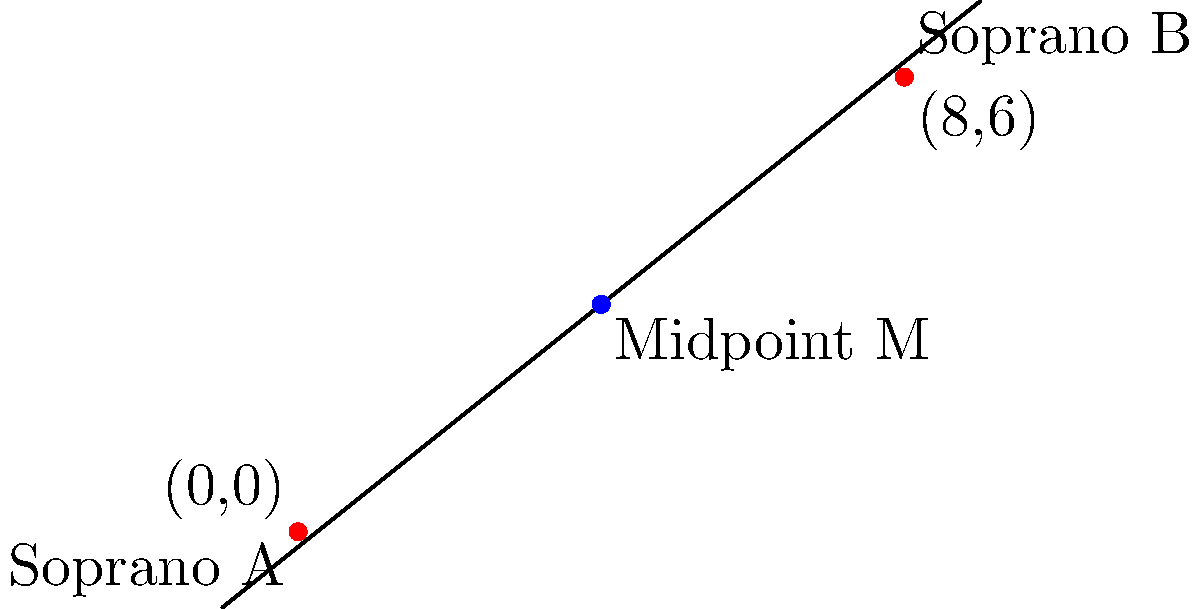Two sopranos, A and B, are positioned on stage at coordinates (0,0) and (8,6) respectively. The conductor wants to find the optimal position for harmonization, which is at the midpoint between the two singers. Calculate the coordinates of this midpoint M. To find the midpoint between two points, we use the midpoint formula:

$$ M = (\frac{x_1 + x_2}{2}, \frac{y_1 + y_2}{2}) $$

Where $(x_1, y_1)$ are the coordinates of point A, and $(x_2, y_2)$ are the coordinates of point B.

Step 1: Identify the coordinates
A: $(x_1, y_1) = (0, 0)$
B: $(x_2, y_2) = (8, 6)$

Step 2: Apply the midpoint formula
$$ M_x = \frac{x_1 + x_2}{2} = \frac{0 + 8}{2} = \frac{8}{2} = 4 $$
$$ M_y = \frac{y_1 + y_2}{2} = \frac{0 + 6}{2} = \frac{6}{2} = 3 $$

Step 3: Combine the results
The midpoint M has coordinates $(4, 3)$.
Answer: (4, 3) 